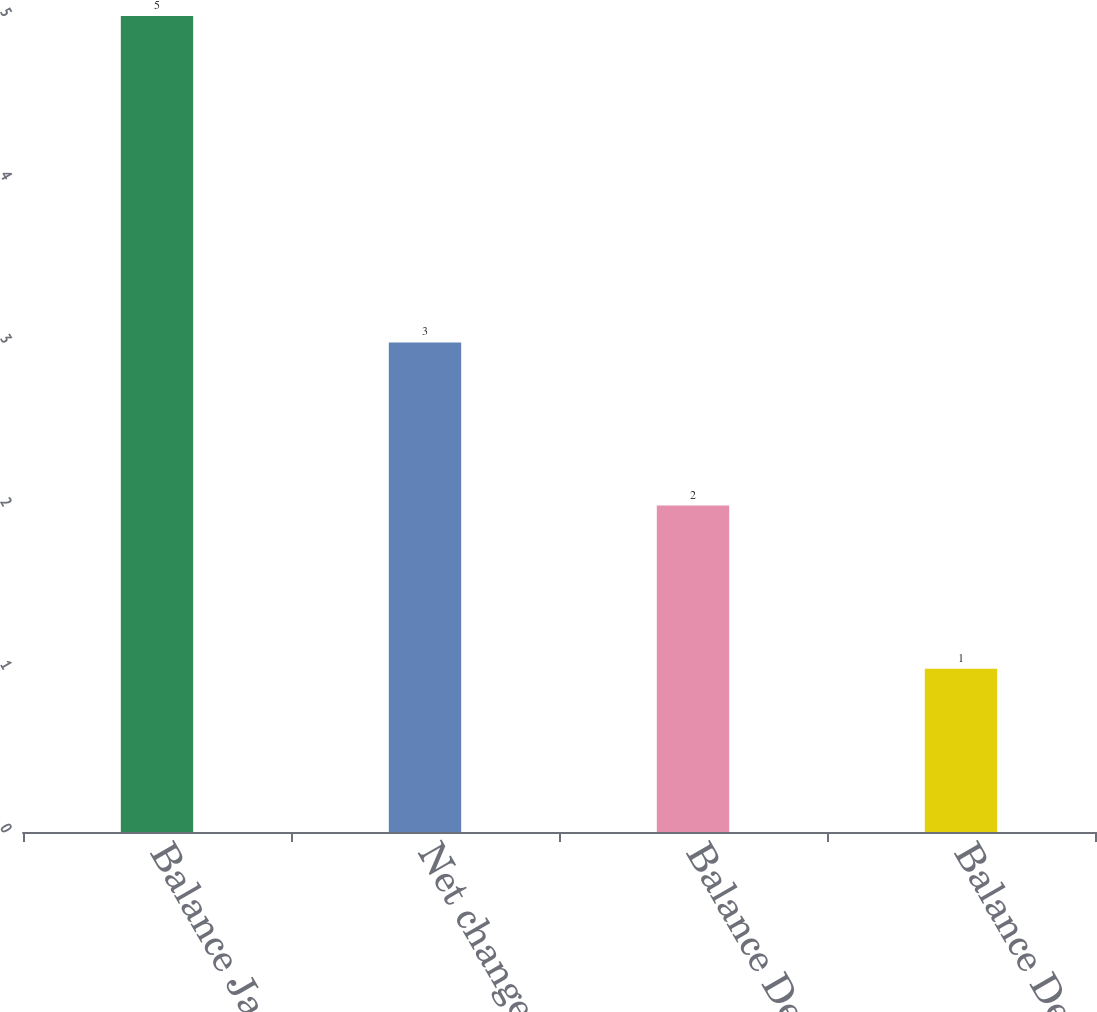<chart> <loc_0><loc_0><loc_500><loc_500><bar_chart><fcel>Balance Jan 1 2003<fcel>Net change<fcel>Balance Dec 31 2003<fcel>Balance Dec 31 2004<nl><fcel>5<fcel>3<fcel>2<fcel>1<nl></chart> 